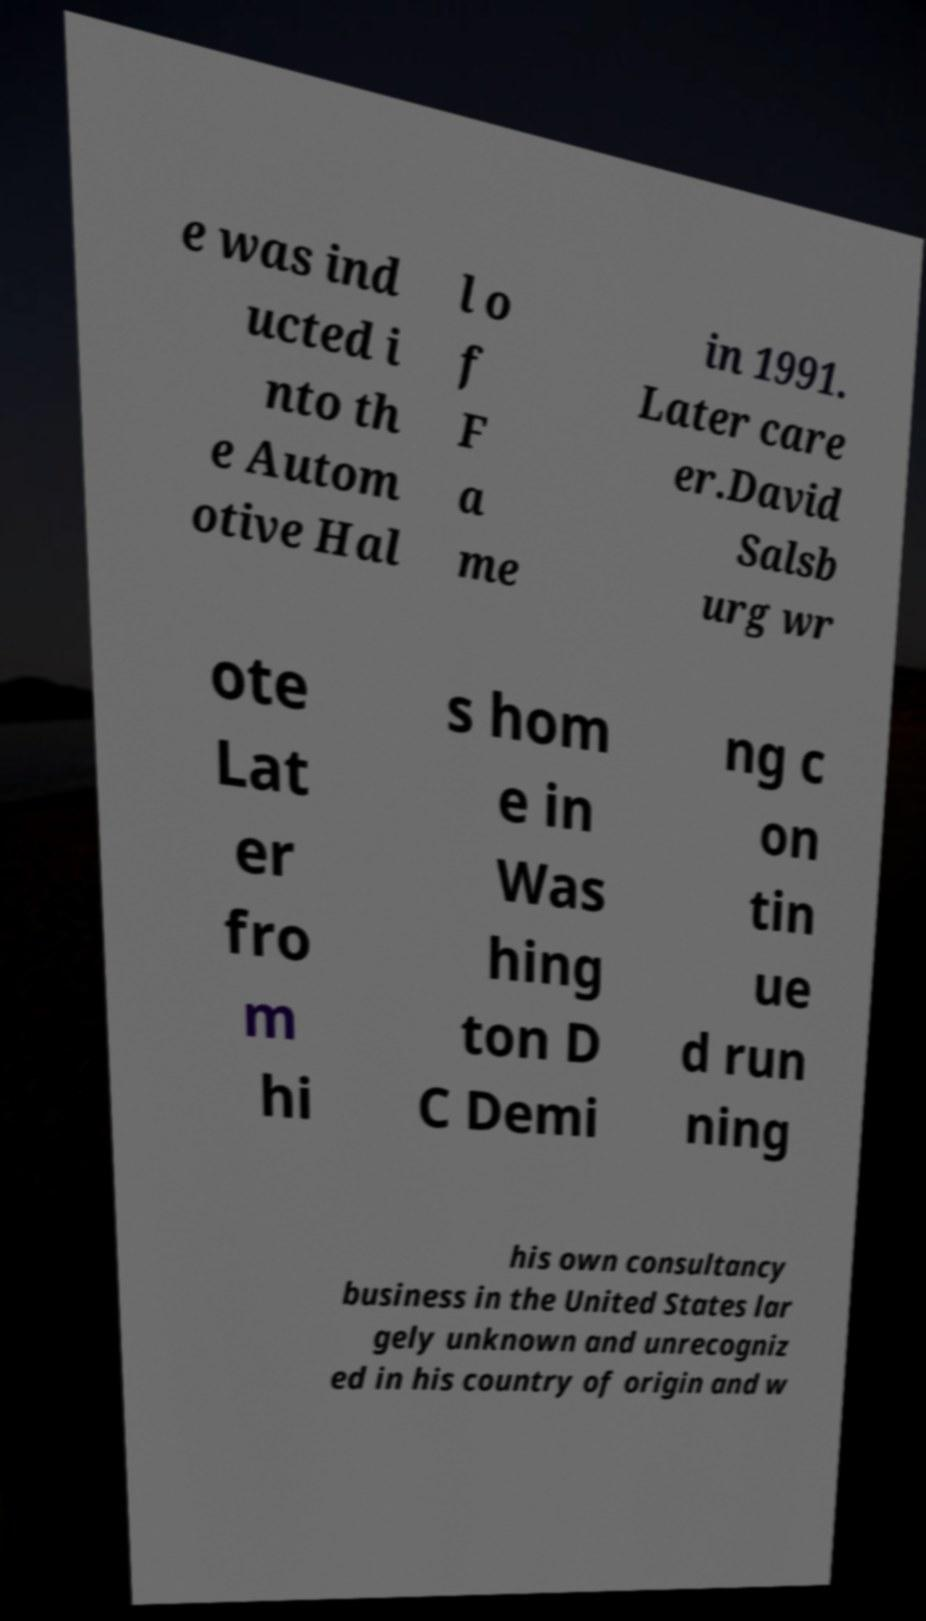There's text embedded in this image that I need extracted. Can you transcribe it verbatim? e was ind ucted i nto th e Autom otive Hal l o f F a me in 1991. Later care er.David Salsb urg wr ote Lat er fro m hi s hom e in Was hing ton D C Demi ng c on tin ue d run ning his own consultancy business in the United States lar gely unknown and unrecogniz ed in his country of origin and w 